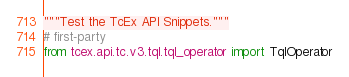Convert code to text. <code><loc_0><loc_0><loc_500><loc_500><_Python_>"""Test the TcEx API Snippets."""
# first-party
from tcex.api.tc.v3.tql.tql_operator import TqlOperator</code> 